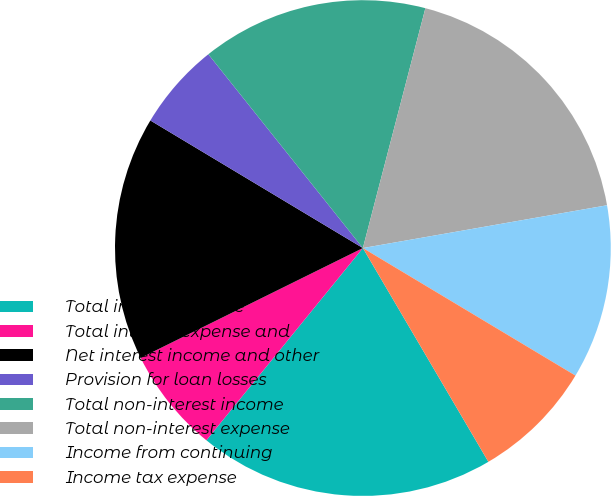Convert chart to OTSL. <chart><loc_0><loc_0><loc_500><loc_500><pie_chart><fcel>Total interest income<fcel>Total interest expense and<fcel>Net interest income and other<fcel>Provision for loan losses<fcel>Total non-interest income<fcel>Total non-interest expense<fcel>Income from continuing<fcel>Income tax expense<nl><fcel>19.32%<fcel>6.82%<fcel>15.91%<fcel>5.68%<fcel>14.77%<fcel>18.18%<fcel>11.36%<fcel>7.95%<nl></chart> 